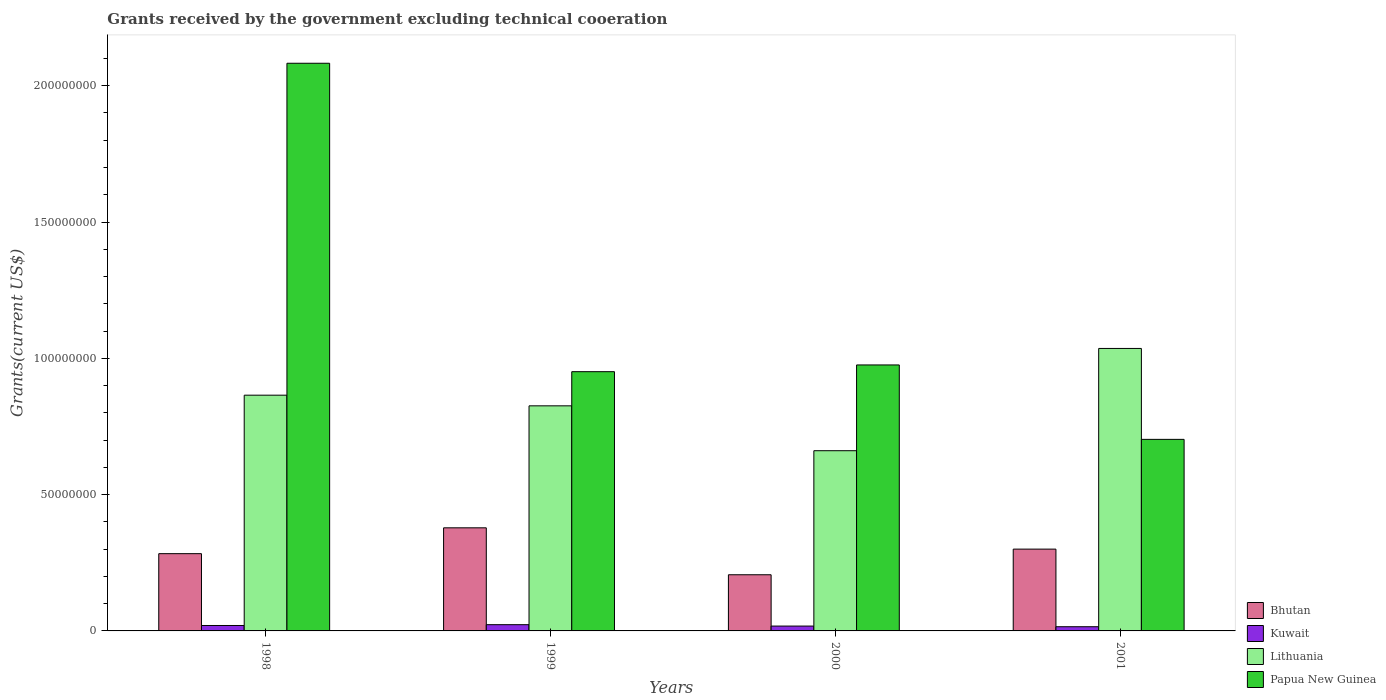How many different coloured bars are there?
Keep it short and to the point. 4. Are the number of bars per tick equal to the number of legend labels?
Offer a very short reply. Yes. How many bars are there on the 4th tick from the left?
Provide a succinct answer. 4. In how many cases, is the number of bars for a given year not equal to the number of legend labels?
Keep it short and to the point. 0. What is the total grants received by the government in Kuwait in 2000?
Make the answer very short. 1.78e+06. Across all years, what is the maximum total grants received by the government in Papua New Guinea?
Your response must be concise. 2.08e+08. Across all years, what is the minimum total grants received by the government in Bhutan?
Provide a succinct answer. 2.06e+07. In which year was the total grants received by the government in Bhutan minimum?
Your answer should be compact. 2000. What is the total total grants received by the government in Kuwait in the graph?
Offer a terse response. 7.60e+06. What is the difference between the total grants received by the government in Kuwait in 1999 and that in 2001?
Ensure brevity in your answer.  7.50e+05. What is the difference between the total grants received by the government in Papua New Guinea in 2001 and the total grants received by the government in Kuwait in 1999?
Ensure brevity in your answer.  6.80e+07. What is the average total grants received by the government in Papua New Guinea per year?
Your answer should be very brief. 1.18e+08. In the year 2001, what is the difference between the total grants received by the government in Papua New Guinea and total grants received by the government in Bhutan?
Your answer should be compact. 4.03e+07. In how many years, is the total grants received by the government in Lithuania greater than 160000000 US$?
Your response must be concise. 0. What is the ratio of the total grants received by the government in Papua New Guinea in 1998 to that in 2000?
Offer a terse response. 2.13. What is the difference between the highest and the second highest total grants received by the government in Lithuania?
Offer a terse response. 1.71e+07. What is the difference between the highest and the lowest total grants received by the government in Bhutan?
Keep it short and to the point. 1.72e+07. In how many years, is the total grants received by the government in Papua New Guinea greater than the average total grants received by the government in Papua New Guinea taken over all years?
Keep it short and to the point. 1. Is the sum of the total grants received by the government in Bhutan in 1998 and 1999 greater than the maximum total grants received by the government in Kuwait across all years?
Ensure brevity in your answer.  Yes. What does the 2nd bar from the left in 2000 represents?
Your response must be concise. Kuwait. What does the 1st bar from the right in 2001 represents?
Offer a very short reply. Papua New Guinea. How many bars are there?
Give a very brief answer. 16. Are all the bars in the graph horizontal?
Provide a short and direct response. No. What is the difference between two consecutive major ticks on the Y-axis?
Make the answer very short. 5.00e+07. Are the values on the major ticks of Y-axis written in scientific E-notation?
Ensure brevity in your answer.  No. Does the graph contain any zero values?
Give a very brief answer. No. How are the legend labels stacked?
Your response must be concise. Vertical. What is the title of the graph?
Offer a terse response. Grants received by the government excluding technical cooeration. What is the label or title of the Y-axis?
Provide a succinct answer. Grants(current US$). What is the Grants(current US$) of Bhutan in 1998?
Your answer should be very brief. 2.83e+07. What is the Grants(current US$) of Kuwait in 1998?
Make the answer very short. 1.99e+06. What is the Grants(current US$) in Lithuania in 1998?
Make the answer very short. 8.65e+07. What is the Grants(current US$) of Papua New Guinea in 1998?
Offer a terse response. 2.08e+08. What is the Grants(current US$) of Bhutan in 1999?
Ensure brevity in your answer.  3.78e+07. What is the Grants(current US$) in Kuwait in 1999?
Your answer should be very brief. 2.29e+06. What is the Grants(current US$) in Lithuania in 1999?
Provide a succinct answer. 8.26e+07. What is the Grants(current US$) of Papua New Guinea in 1999?
Keep it short and to the point. 9.51e+07. What is the Grants(current US$) of Bhutan in 2000?
Provide a succinct answer. 2.06e+07. What is the Grants(current US$) in Kuwait in 2000?
Your answer should be very brief. 1.78e+06. What is the Grants(current US$) of Lithuania in 2000?
Give a very brief answer. 6.61e+07. What is the Grants(current US$) in Papua New Guinea in 2000?
Offer a terse response. 9.76e+07. What is the Grants(current US$) of Bhutan in 2001?
Your response must be concise. 3.00e+07. What is the Grants(current US$) in Kuwait in 2001?
Offer a terse response. 1.54e+06. What is the Grants(current US$) of Lithuania in 2001?
Provide a short and direct response. 1.04e+08. What is the Grants(current US$) of Papua New Guinea in 2001?
Give a very brief answer. 7.03e+07. Across all years, what is the maximum Grants(current US$) of Bhutan?
Your answer should be compact. 3.78e+07. Across all years, what is the maximum Grants(current US$) in Kuwait?
Offer a very short reply. 2.29e+06. Across all years, what is the maximum Grants(current US$) in Lithuania?
Your answer should be compact. 1.04e+08. Across all years, what is the maximum Grants(current US$) of Papua New Guinea?
Provide a short and direct response. 2.08e+08. Across all years, what is the minimum Grants(current US$) of Bhutan?
Provide a succinct answer. 2.06e+07. Across all years, what is the minimum Grants(current US$) in Kuwait?
Offer a terse response. 1.54e+06. Across all years, what is the minimum Grants(current US$) of Lithuania?
Offer a terse response. 6.61e+07. Across all years, what is the minimum Grants(current US$) in Papua New Guinea?
Give a very brief answer. 7.03e+07. What is the total Grants(current US$) of Bhutan in the graph?
Give a very brief answer. 1.17e+08. What is the total Grants(current US$) of Kuwait in the graph?
Give a very brief answer. 7.60e+06. What is the total Grants(current US$) in Lithuania in the graph?
Ensure brevity in your answer.  3.39e+08. What is the total Grants(current US$) in Papua New Guinea in the graph?
Keep it short and to the point. 4.71e+08. What is the difference between the Grants(current US$) in Bhutan in 1998 and that in 1999?
Offer a very short reply. -9.48e+06. What is the difference between the Grants(current US$) of Kuwait in 1998 and that in 1999?
Give a very brief answer. -3.00e+05. What is the difference between the Grants(current US$) in Lithuania in 1998 and that in 1999?
Your response must be concise. 3.91e+06. What is the difference between the Grants(current US$) in Papua New Guinea in 1998 and that in 1999?
Make the answer very short. 1.13e+08. What is the difference between the Grants(current US$) of Bhutan in 1998 and that in 2000?
Offer a terse response. 7.74e+06. What is the difference between the Grants(current US$) of Kuwait in 1998 and that in 2000?
Keep it short and to the point. 2.10e+05. What is the difference between the Grants(current US$) in Lithuania in 1998 and that in 2000?
Your response must be concise. 2.04e+07. What is the difference between the Grants(current US$) of Papua New Guinea in 1998 and that in 2000?
Ensure brevity in your answer.  1.11e+08. What is the difference between the Grants(current US$) in Bhutan in 1998 and that in 2001?
Your answer should be very brief. -1.67e+06. What is the difference between the Grants(current US$) of Lithuania in 1998 and that in 2001?
Provide a short and direct response. -1.71e+07. What is the difference between the Grants(current US$) in Papua New Guinea in 1998 and that in 2001?
Give a very brief answer. 1.38e+08. What is the difference between the Grants(current US$) of Bhutan in 1999 and that in 2000?
Your answer should be very brief. 1.72e+07. What is the difference between the Grants(current US$) in Kuwait in 1999 and that in 2000?
Provide a short and direct response. 5.10e+05. What is the difference between the Grants(current US$) in Lithuania in 1999 and that in 2000?
Offer a very short reply. 1.65e+07. What is the difference between the Grants(current US$) in Papua New Guinea in 1999 and that in 2000?
Ensure brevity in your answer.  -2.47e+06. What is the difference between the Grants(current US$) in Bhutan in 1999 and that in 2001?
Provide a succinct answer. 7.81e+06. What is the difference between the Grants(current US$) in Kuwait in 1999 and that in 2001?
Give a very brief answer. 7.50e+05. What is the difference between the Grants(current US$) of Lithuania in 1999 and that in 2001?
Offer a terse response. -2.10e+07. What is the difference between the Grants(current US$) in Papua New Guinea in 1999 and that in 2001?
Give a very brief answer. 2.48e+07. What is the difference between the Grants(current US$) in Bhutan in 2000 and that in 2001?
Offer a terse response. -9.41e+06. What is the difference between the Grants(current US$) of Kuwait in 2000 and that in 2001?
Your answer should be compact. 2.40e+05. What is the difference between the Grants(current US$) of Lithuania in 2000 and that in 2001?
Ensure brevity in your answer.  -3.75e+07. What is the difference between the Grants(current US$) of Papua New Guinea in 2000 and that in 2001?
Provide a short and direct response. 2.73e+07. What is the difference between the Grants(current US$) of Bhutan in 1998 and the Grants(current US$) of Kuwait in 1999?
Your response must be concise. 2.60e+07. What is the difference between the Grants(current US$) of Bhutan in 1998 and the Grants(current US$) of Lithuania in 1999?
Your answer should be very brief. -5.42e+07. What is the difference between the Grants(current US$) in Bhutan in 1998 and the Grants(current US$) in Papua New Guinea in 1999?
Your answer should be compact. -6.68e+07. What is the difference between the Grants(current US$) of Kuwait in 1998 and the Grants(current US$) of Lithuania in 1999?
Provide a short and direct response. -8.06e+07. What is the difference between the Grants(current US$) of Kuwait in 1998 and the Grants(current US$) of Papua New Guinea in 1999?
Your answer should be very brief. -9.31e+07. What is the difference between the Grants(current US$) in Lithuania in 1998 and the Grants(current US$) in Papua New Guinea in 1999?
Give a very brief answer. -8.62e+06. What is the difference between the Grants(current US$) of Bhutan in 1998 and the Grants(current US$) of Kuwait in 2000?
Provide a succinct answer. 2.66e+07. What is the difference between the Grants(current US$) in Bhutan in 1998 and the Grants(current US$) in Lithuania in 2000?
Provide a short and direct response. -3.78e+07. What is the difference between the Grants(current US$) in Bhutan in 1998 and the Grants(current US$) in Papua New Guinea in 2000?
Provide a succinct answer. -6.92e+07. What is the difference between the Grants(current US$) of Kuwait in 1998 and the Grants(current US$) of Lithuania in 2000?
Ensure brevity in your answer.  -6.41e+07. What is the difference between the Grants(current US$) of Kuwait in 1998 and the Grants(current US$) of Papua New Guinea in 2000?
Make the answer very short. -9.56e+07. What is the difference between the Grants(current US$) in Lithuania in 1998 and the Grants(current US$) in Papua New Guinea in 2000?
Give a very brief answer. -1.11e+07. What is the difference between the Grants(current US$) in Bhutan in 1998 and the Grants(current US$) in Kuwait in 2001?
Provide a short and direct response. 2.68e+07. What is the difference between the Grants(current US$) of Bhutan in 1998 and the Grants(current US$) of Lithuania in 2001?
Your response must be concise. -7.53e+07. What is the difference between the Grants(current US$) in Bhutan in 1998 and the Grants(current US$) in Papua New Guinea in 2001?
Offer a very short reply. -4.19e+07. What is the difference between the Grants(current US$) of Kuwait in 1998 and the Grants(current US$) of Lithuania in 2001?
Offer a very short reply. -1.02e+08. What is the difference between the Grants(current US$) in Kuwait in 1998 and the Grants(current US$) in Papua New Guinea in 2001?
Offer a very short reply. -6.83e+07. What is the difference between the Grants(current US$) of Lithuania in 1998 and the Grants(current US$) of Papua New Guinea in 2001?
Offer a very short reply. 1.62e+07. What is the difference between the Grants(current US$) in Bhutan in 1999 and the Grants(current US$) in Kuwait in 2000?
Your answer should be compact. 3.60e+07. What is the difference between the Grants(current US$) of Bhutan in 1999 and the Grants(current US$) of Lithuania in 2000?
Offer a very short reply. -2.83e+07. What is the difference between the Grants(current US$) in Bhutan in 1999 and the Grants(current US$) in Papua New Guinea in 2000?
Make the answer very short. -5.98e+07. What is the difference between the Grants(current US$) in Kuwait in 1999 and the Grants(current US$) in Lithuania in 2000?
Ensure brevity in your answer.  -6.38e+07. What is the difference between the Grants(current US$) of Kuwait in 1999 and the Grants(current US$) of Papua New Guinea in 2000?
Your response must be concise. -9.53e+07. What is the difference between the Grants(current US$) in Lithuania in 1999 and the Grants(current US$) in Papua New Guinea in 2000?
Your response must be concise. -1.50e+07. What is the difference between the Grants(current US$) in Bhutan in 1999 and the Grants(current US$) in Kuwait in 2001?
Give a very brief answer. 3.63e+07. What is the difference between the Grants(current US$) in Bhutan in 1999 and the Grants(current US$) in Lithuania in 2001?
Provide a succinct answer. -6.58e+07. What is the difference between the Grants(current US$) in Bhutan in 1999 and the Grants(current US$) in Papua New Guinea in 2001?
Keep it short and to the point. -3.24e+07. What is the difference between the Grants(current US$) in Kuwait in 1999 and the Grants(current US$) in Lithuania in 2001?
Give a very brief answer. -1.01e+08. What is the difference between the Grants(current US$) in Kuwait in 1999 and the Grants(current US$) in Papua New Guinea in 2001?
Your answer should be compact. -6.80e+07. What is the difference between the Grants(current US$) of Lithuania in 1999 and the Grants(current US$) of Papua New Guinea in 2001?
Give a very brief answer. 1.23e+07. What is the difference between the Grants(current US$) of Bhutan in 2000 and the Grants(current US$) of Kuwait in 2001?
Offer a terse response. 1.91e+07. What is the difference between the Grants(current US$) of Bhutan in 2000 and the Grants(current US$) of Lithuania in 2001?
Your response must be concise. -8.30e+07. What is the difference between the Grants(current US$) in Bhutan in 2000 and the Grants(current US$) in Papua New Guinea in 2001?
Your response must be concise. -4.97e+07. What is the difference between the Grants(current US$) in Kuwait in 2000 and the Grants(current US$) in Lithuania in 2001?
Keep it short and to the point. -1.02e+08. What is the difference between the Grants(current US$) of Kuwait in 2000 and the Grants(current US$) of Papua New Guinea in 2001?
Make the answer very short. -6.85e+07. What is the difference between the Grants(current US$) in Lithuania in 2000 and the Grants(current US$) in Papua New Guinea in 2001?
Ensure brevity in your answer.  -4.16e+06. What is the average Grants(current US$) in Bhutan per year?
Ensure brevity in your answer.  2.92e+07. What is the average Grants(current US$) in Kuwait per year?
Offer a very short reply. 1.90e+06. What is the average Grants(current US$) in Lithuania per year?
Make the answer very short. 8.47e+07. What is the average Grants(current US$) in Papua New Guinea per year?
Ensure brevity in your answer.  1.18e+08. In the year 1998, what is the difference between the Grants(current US$) of Bhutan and Grants(current US$) of Kuwait?
Offer a very short reply. 2.64e+07. In the year 1998, what is the difference between the Grants(current US$) in Bhutan and Grants(current US$) in Lithuania?
Keep it short and to the point. -5.81e+07. In the year 1998, what is the difference between the Grants(current US$) of Bhutan and Grants(current US$) of Papua New Guinea?
Make the answer very short. -1.80e+08. In the year 1998, what is the difference between the Grants(current US$) in Kuwait and Grants(current US$) in Lithuania?
Offer a terse response. -8.45e+07. In the year 1998, what is the difference between the Grants(current US$) in Kuwait and Grants(current US$) in Papua New Guinea?
Make the answer very short. -2.06e+08. In the year 1998, what is the difference between the Grants(current US$) in Lithuania and Grants(current US$) in Papua New Guinea?
Keep it short and to the point. -1.22e+08. In the year 1999, what is the difference between the Grants(current US$) of Bhutan and Grants(current US$) of Kuwait?
Keep it short and to the point. 3.55e+07. In the year 1999, what is the difference between the Grants(current US$) of Bhutan and Grants(current US$) of Lithuania?
Provide a succinct answer. -4.48e+07. In the year 1999, what is the difference between the Grants(current US$) in Bhutan and Grants(current US$) in Papua New Guinea?
Make the answer very short. -5.73e+07. In the year 1999, what is the difference between the Grants(current US$) of Kuwait and Grants(current US$) of Lithuania?
Make the answer very short. -8.03e+07. In the year 1999, what is the difference between the Grants(current US$) in Kuwait and Grants(current US$) in Papua New Guinea?
Offer a very short reply. -9.28e+07. In the year 1999, what is the difference between the Grants(current US$) of Lithuania and Grants(current US$) of Papua New Guinea?
Provide a succinct answer. -1.25e+07. In the year 2000, what is the difference between the Grants(current US$) of Bhutan and Grants(current US$) of Kuwait?
Ensure brevity in your answer.  1.88e+07. In the year 2000, what is the difference between the Grants(current US$) in Bhutan and Grants(current US$) in Lithuania?
Provide a succinct answer. -4.55e+07. In the year 2000, what is the difference between the Grants(current US$) in Bhutan and Grants(current US$) in Papua New Guinea?
Offer a very short reply. -7.70e+07. In the year 2000, what is the difference between the Grants(current US$) in Kuwait and Grants(current US$) in Lithuania?
Offer a very short reply. -6.43e+07. In the year 2000, what is the difference between the Grants(current US$) in Kuwait and Grants(current US$) in Papua New Guinea?
Give a very brief answer. -9.58e+07. In the year 2000, what is the difference between the Grants(current US$) of Lithuania and Grants(current US$) of Papua New Guinea?
Ensure brevity in your answer.  -3.15e+07. In the year 2001, what is the difference between the Grants(current US$) in Bhutan and Grants(current US$) in Kuwait?
Make the answer very short. 2.85e+07. In the year 2001, what is the difference between the Grants(current US$) of Bhutan and Grants(current US$) of Lithuania?
Your response must be concise. -7.36e+07. In the year 2001, what is the difference between the Grants(current US$) of Bhutan and Grants(current US$) of Papua New Guinea?
Offer a terse response. -4.03e+07. In the year 2001, what is the difference between the Grants(current US$) of Kuwait and Grants(current US$) of Lithuania?
Your answer should be compact. -1.02e+08. In the year 2001, what is the difference between the Grants(current US$) of Kuwait and Grants(current US$) of Papua New Guinea?
Offer a very short reply. -6.87e+07. In the year 2001, what is the difference between the Grants(current US$) of Lithuania and Grants(current US$) of Papua New Guinea?
Keep it short and to the point. 3.34e+07. What is the ratio of the Grants(current US$) of Bhutan in 1998 to that in 1999?
Ensure brevity in your answer.  0.75. What is the ratio of the Grants(current US$) in Kuwait in 1998 to that in 1999?
Ensure brevity in your answer.  0.87. What is the ratio of the Grants(current US$) in Lithuania in 1998 to that in 1999?
Make the answer very short. 1.05. What is the ratio of the Grants(current US$) of Papua New Guinea in 1998 to that in 1999?
Your response must be concise. 2.19. What is the ratio of the Grants(current US$) in Bhutan in 1998 to that in 2000?
Provide a succinct answer. 1.38. What is the ratio of the Grants(current US$) of Kuwait in 1998 to that in 2000?
Give a very brief answer. 1.12. What is the ratio of the Grants(current US$) of Lithuania in 1998 to that in 2000?
Your answer should be compact. 1.31. What is the ratio of the Grants(current US$) in Papua New Guinea in 1998 to that in 2000?
Offer a terse response. 2.13. What is the ratio of the Grants(current US$) in Kuwait in 1998 to that in 2001?
Your response must be concise. 1.29. What is the ratio of the Grants(current US$) in Lithuania in 1998 to that in 2001?
Make the answer very short. 0.83. What is the ratio of the Grants(current US$) of Papua New Guinea in 1998 to that in 2001?
Your answer should be compact. 2.96. What is the ratio of the Grants(current US$) of Bhutan in 1999 to that in 2000?
Your answer should be very brief. 1.84. What is the ratio of the Grants(current US$) in Kuwait in 1999 to that in 2000?
Your answer should be very brief. 1.29. What is the ratio of the Grants(current US$) in Lithuania in 1999 to that in 2000?
Your answer should be compact. 1.25. What is the ratio of the Grants(current US$) in Papua New Guinea in 1999 to that in 2000?
Provide a succinct answer. 0.97. What is the ratio of the Grants(current US$) of Bhutan in 1999 to that in 2001?
Ensure brevity in your answer.  1.26. What is the ratio of the Grants(current US$) in Kuwait in 1999 to that in 2001?
Give a very brief answer. 1.49. What is the ratio of the Grants(current US$) in Lithuania in 1999 to that in 2001?
Give a very brief answer. 0.8. What is the ratio of the Grants(current US$) of Papua New Guinea in 1999 to that in 2001?
Your response must be concise. 1.35. What is the ratio of the Grants(current US$) in Bhutan in 2000 to that in 2001?
Give a very brief answer. 0.69. What is the ratio of the Grants(current US$) in Kuwait in 2000 to that in 2001?
Give a very brief answer. 1.16. What is the ratio of the Grants(current US$) in Lithuania in 2000 to that in 2001?
Offer a very short reply. 0.64. What is the ratio of the Grants(current US$) of Papua New Guinea in 2000 to that in 2001?
Make the answer very short. 1.39. What is the difference between the highest and the second highest Grants(current US$) of Bhutan?
Give a very brief answer. 7.81e+06. What is the difference between the highest and the second highest Grants(current US$) of Kuwait?
Keep it short and to the point. 3.00e+05. What is the difference between the highest and the second highest Grants(current US$) in Lithuania?
Offer a terse response. 1.71e+07. What is the difference between the highest and the second highest Grants(current US$) in Papua New Guinea?
Your answer should be compact. 1.11e+08. What is the difference between the highest and the lowest Grants(current US$) in Bhutan?
Offer a terse response. 1.72e+07. What is the difference between the highest and the lowest Grants(current US$) in Kuwait?
Offer a very short reply. 7.50e+05. What is the difference between the highest and the lowest Grants(current US$) in Lithuania?
Provide a succinct answer. 3.75e+07. What is the difference between the highest and the lowest Grants(current US$) in Papua New Guinea?
Your response must be concise. 1.38e+08. 